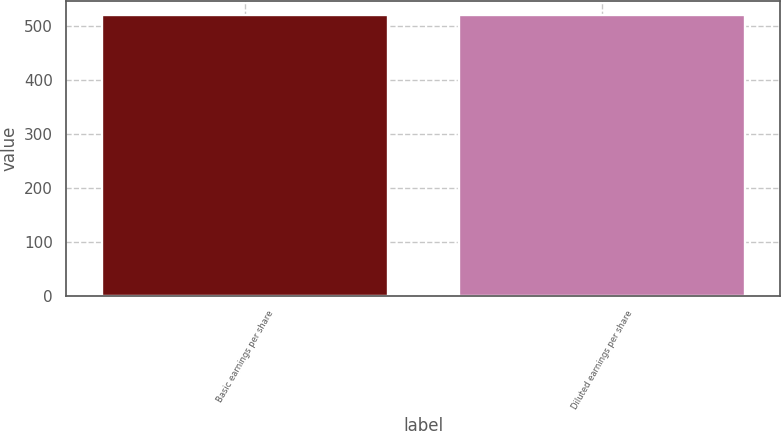Convert chart to OTSL. <chart><loc_0><loc_0><loc_500><loc_500><bar_chart><fcel>Basic earnings per share<fcel>Diluted earnings per share<nl><fcel>519.7<fcel>519.8<nl></chart> 